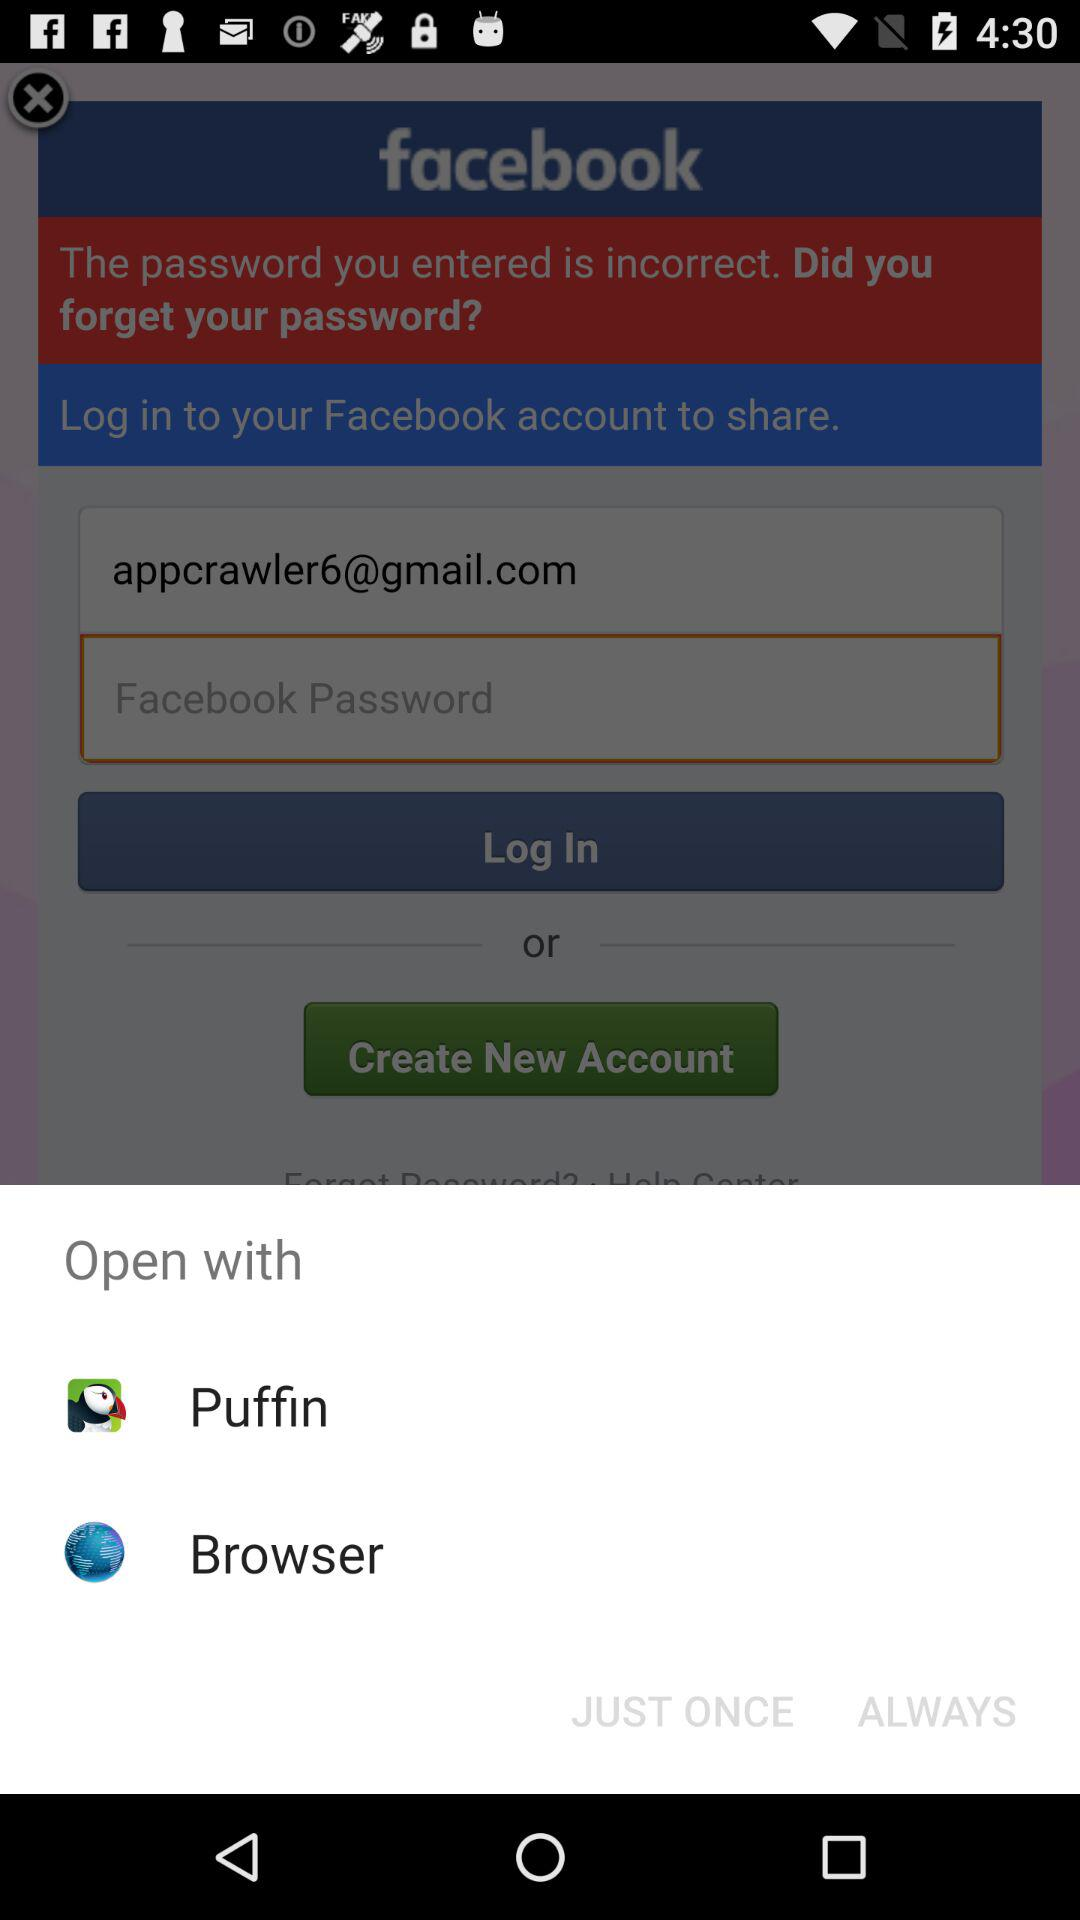Which application can I use to share? The applications that you can use to share are "Puffin" and "Browser". 